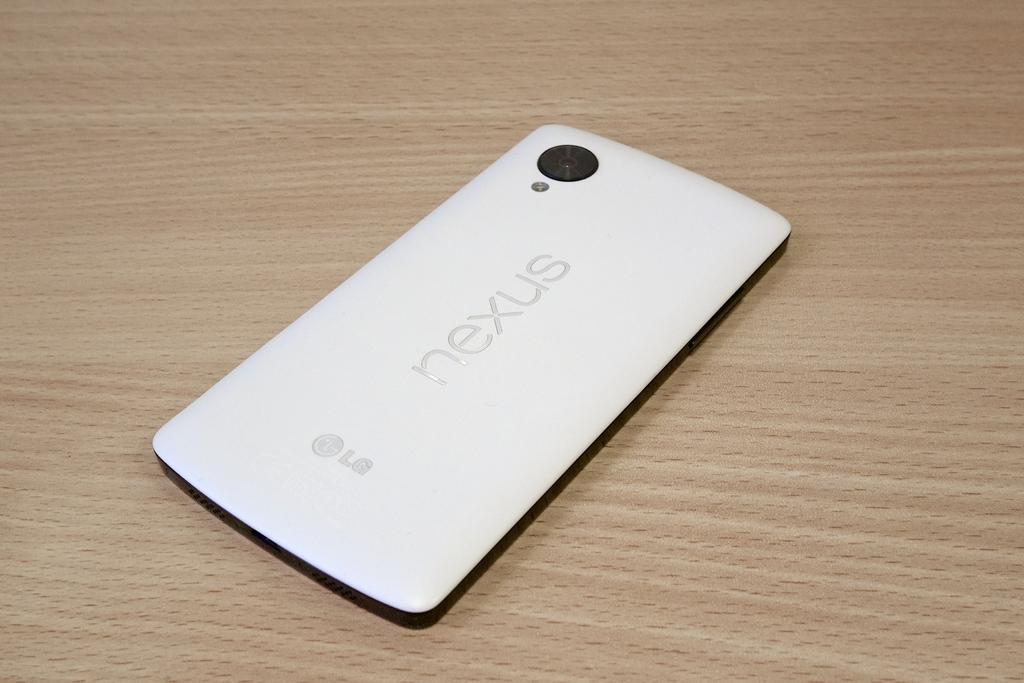What is the main subject of the image? The main subject of the image is the backside of a mobile device. What color is the mobile device? The mobile device is white in color. Are there any markings or text on the mobile device? Yes, there is text written on the mobile device. What type of underwear is visible on the backside of the mobile device? There is no underwear visible on the backside of the mobile device; it is a mobile device, not a person wearing underwear. 